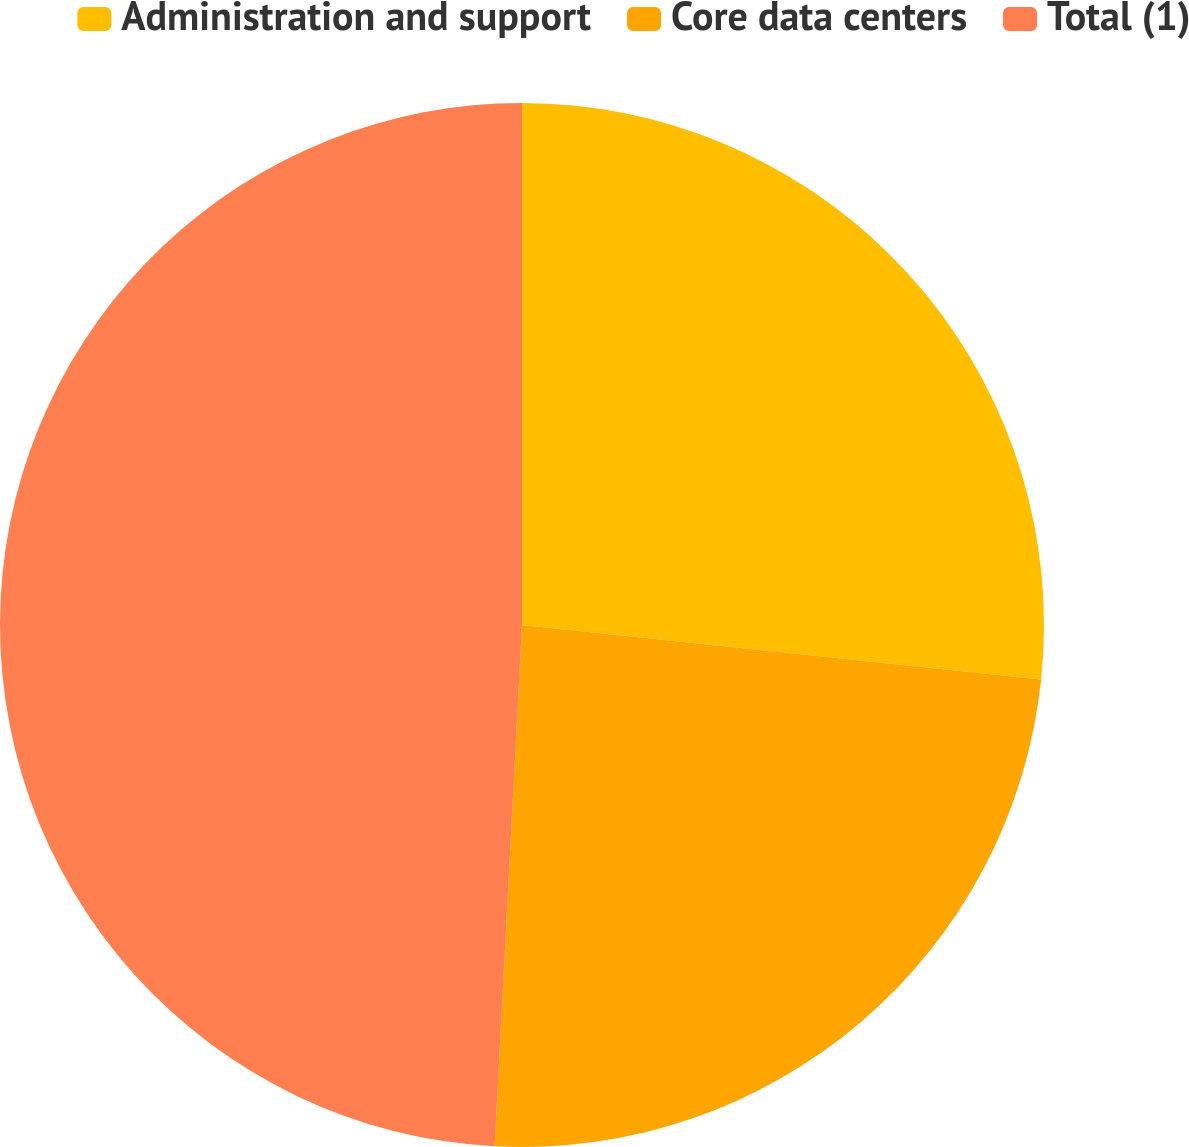Convert chart to OTSL. <chart><loc_0><loc_0><loc_500><loc_500><pie_chart><fcel>Administration and support<fcel>Core data centers<fcel>Total (1)<nl><fcel>26.67%<fcel>24.17%<fcel>49.17%<nl></chart> 